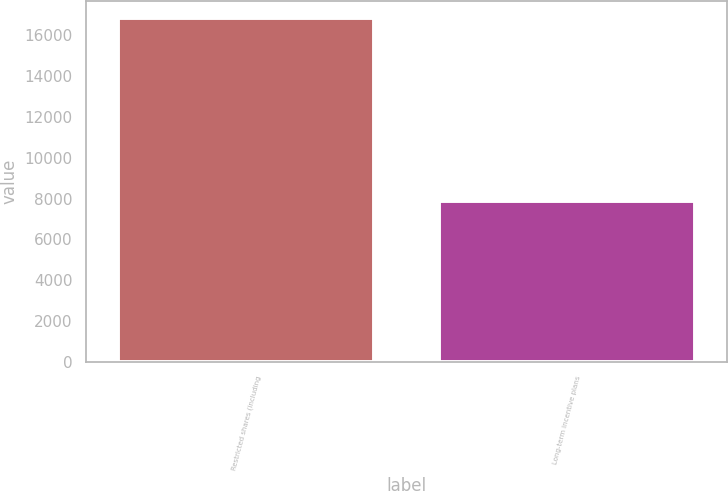<chart> <loc_0><loc_0><loc_500><loc_500><bar_chart><fcel>Restricted shares (including<fcel>Long-term incentive plans<nl><fcel>16852<fcel>7863<nl></chart> 